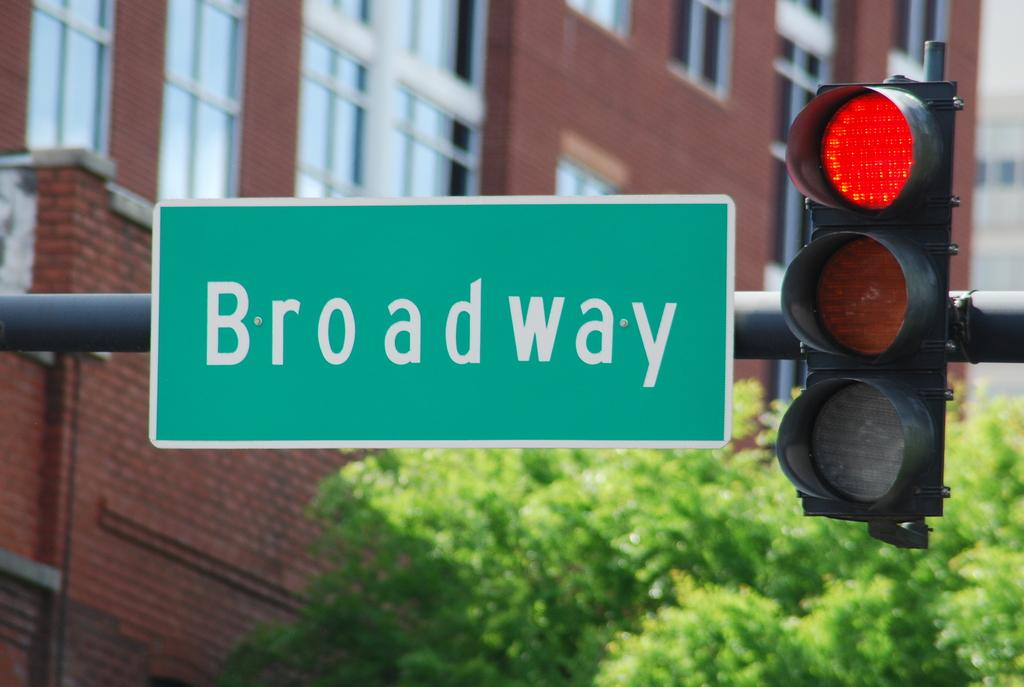<image>
Render a clear and concise summary of the photo. A red traffic light and a Broadway street sign. 